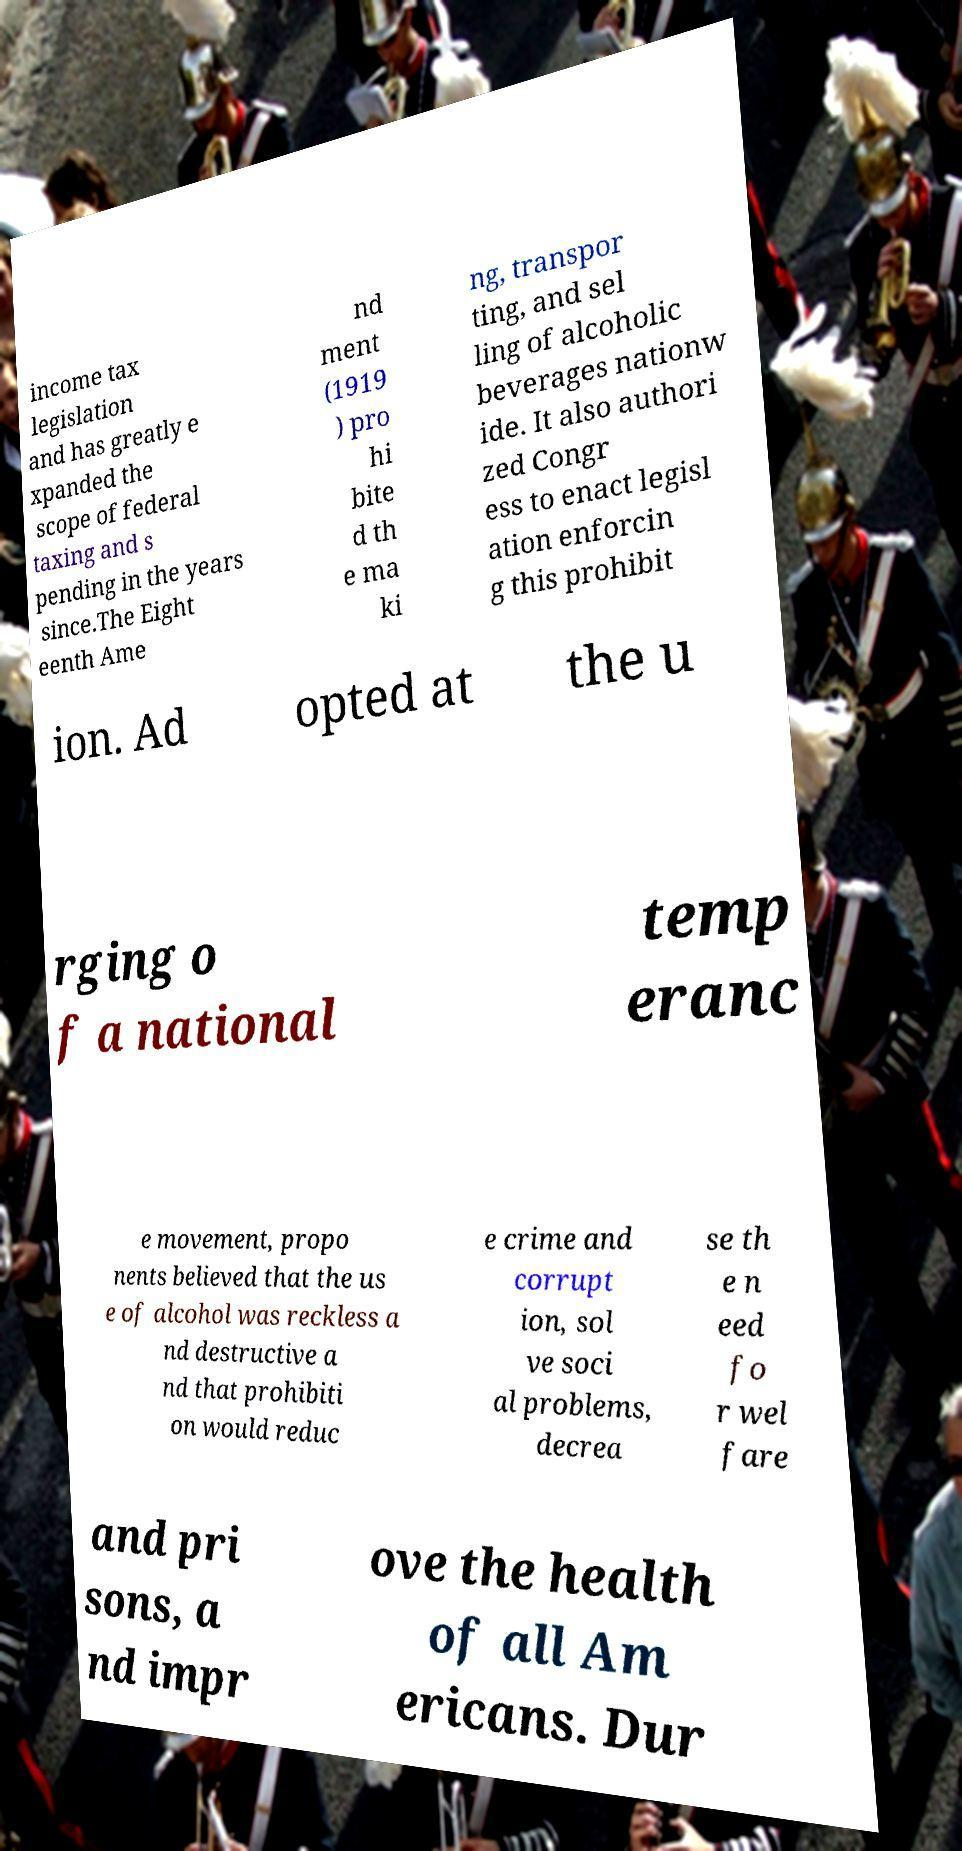Can you read and provide the text displayed in the image?This photo seems to have some interesting text. Can you extract and type it out for me? income tax legislation and has greatly e xpanded the scope of federal taxing and s pending in the years since.The Eight eenth Ame nd ment (1919 ) pro hi bite d th e ma ki ng, transpor ting, and sel ling of alcoholic beverages nationw ide. It also authori zed Congr ess to enact legisl ation enforcin g this prohibit ion. Ad opted at the u rging o f a national temp eranc e movement, propo nents believed that the us e of alcohol was reckless a nd destructive a nd that prohibiti on would reduc e crime and corrupt ion, sol ve soci al problems, decrea se th e n eed fo r wel fare and pri sons, a nd impr ove the health of all Am ericans. Dur 